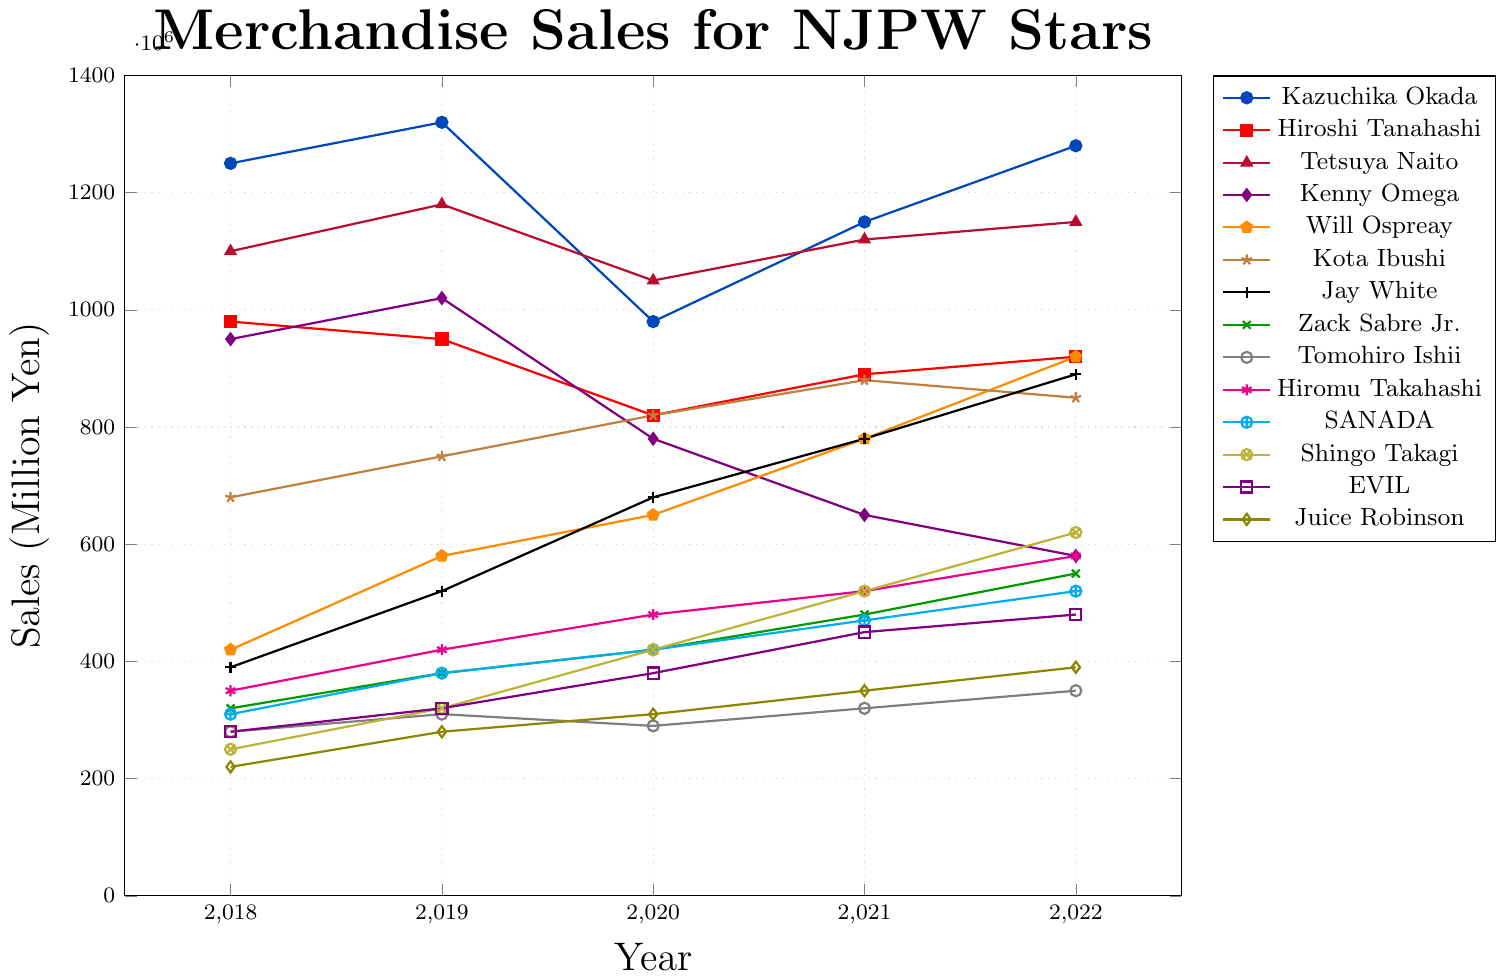Who had the highest merchandise sales in 2022? To determine who had the highest merchandise sales in 2022, identify the star whose data point is at the highest position on the y-axis for the year 2022. Kazuchika Okada's data point is at the highest position.
Answer: Kazuchika Okada How did Kenny Omega's sales change from 2018 to 2022? To see how Kenny Omega's sales changed, look at the trend of his data points from 2018 to 2022. The sales decrease from 950,000 in 2018 to 580,000 in 2022.
Answer: They decreased Which star had the most significant increase in sales from 2018 to 2022? Compare the starting and ending points of sales for each star between 2018 and 2022. Will Ospreay starts at 420,000 in 2018 and ends at 920,000 in 2022, which is the largest increase.
Answer: Will Ospreay What is the average merchandise sales of Hiroshi Tanahashi over the five years? Sum the sales of Hiroshi Tanahashi for each year: 980,000 + 950,000 + 820,000 + 890,000 + 920,000. The sum is 4,560,000. Divide by 5 to get the average.
Answer: 912,000 How do Tetsuya Naito’s sales in 2020 compare to Kazuchika Okada’s sales in 2020? Look at the data points for 2020 for both Tetsuya Naito and Kazuchika Okada. Naito’s sales are 1,050,000; Okada’s are 980,000. Compare the two values.
Answer: Naito's sales were higher Which year's sales did Zack Sabre Jr. see the smallest increase compared to the previous year? Calculate the year-to-year changes for Zack Sabre Jr.: 
2018 to 2019: 380,000 - 320,000 = 60,000 
2019 to 2020: 420,000 - 380,000 = 40,000 
2020 to 2021: 480,000 - 420,000 = 60,000 
2021 to 2022: 550,000 - 480,000 = 70,000. The smallest increase is between 2019 and 2020.
Answer: 2020 Who had higher sales in 2021, Kota Ibushi or Jay White? In 2021, check the data points for both Kota Ibushi and Jay White. Kota Ibushi’s sales are 880,000 and Jay White’s sales are 780,000. So, Kota Ibushi had higher sales.
Answer: Kota Ibushi What is the total merchandise sales for Hiromu Takahashi across all five years? Sum the sales of Hiromu Takahashi for each year: 350,000 + 420,000 + 480,000 + 520,000 + 580,000. The total is 2,350,000.
Answer: 2,350,000 Which star had the least fluctuation in sales over the five years? Observe the sales numbers for all stars and identify the one whose values are most consistent with the least change. Tomohiro Ishii’s sales are relatively stable: 280,000, 310,000, 290,000, 320,000, 350,000.
Answer: Tomohiro Ishii 